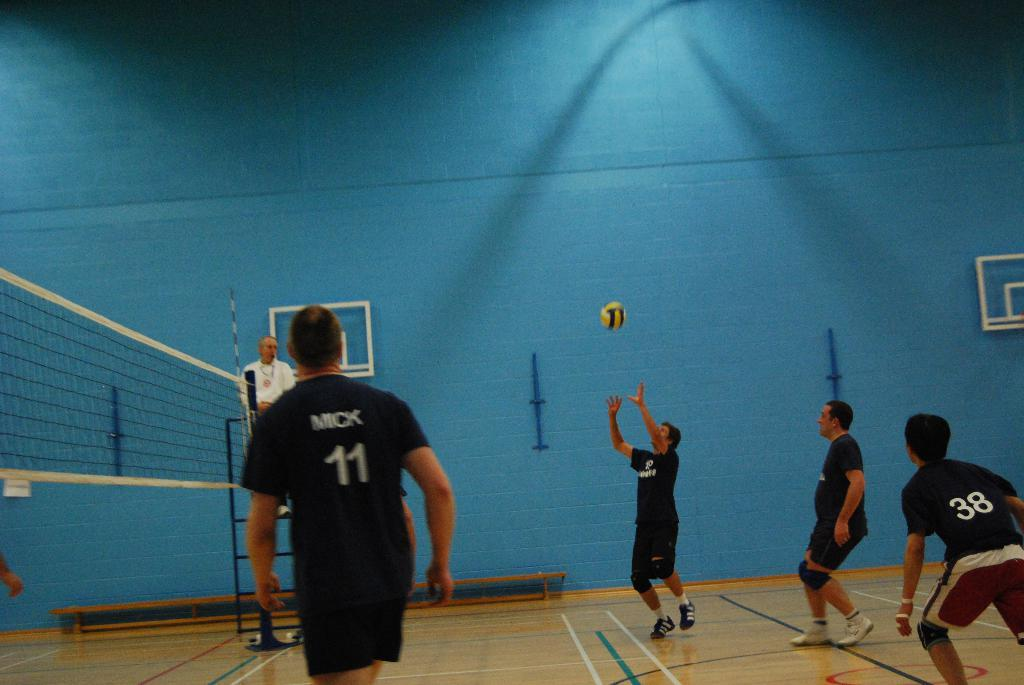<image>
Write a terse but informative summary of the picture. Mick 11 waits for the ball to come his way 